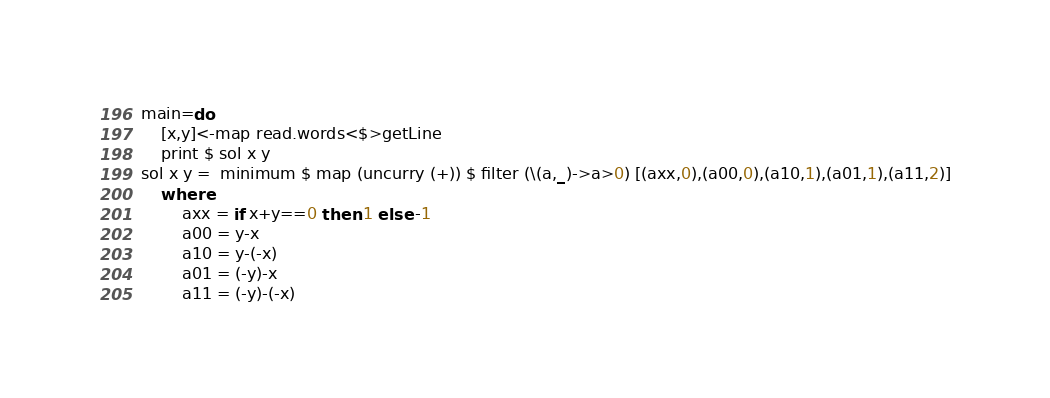<code> <loc_0><loc_0><loc_500><loc_500><_Haskell_>main=do
    [x,y]<-map read.words<$>getLine
    print $ sol x y
sol x y =  minimum $ map (uncurry (+)) $ filter (\(a,_)->a>0) [(axx,0),(a00,0),(a10,1),(a01,1),(a11,2)]
    where
        axx = if x+y==0 then 1 else -1
        a00 = y-x
        a10 = y-(-x)
        a01 = (-y)-x
        a11 = (-y)-(-x)
</code> 